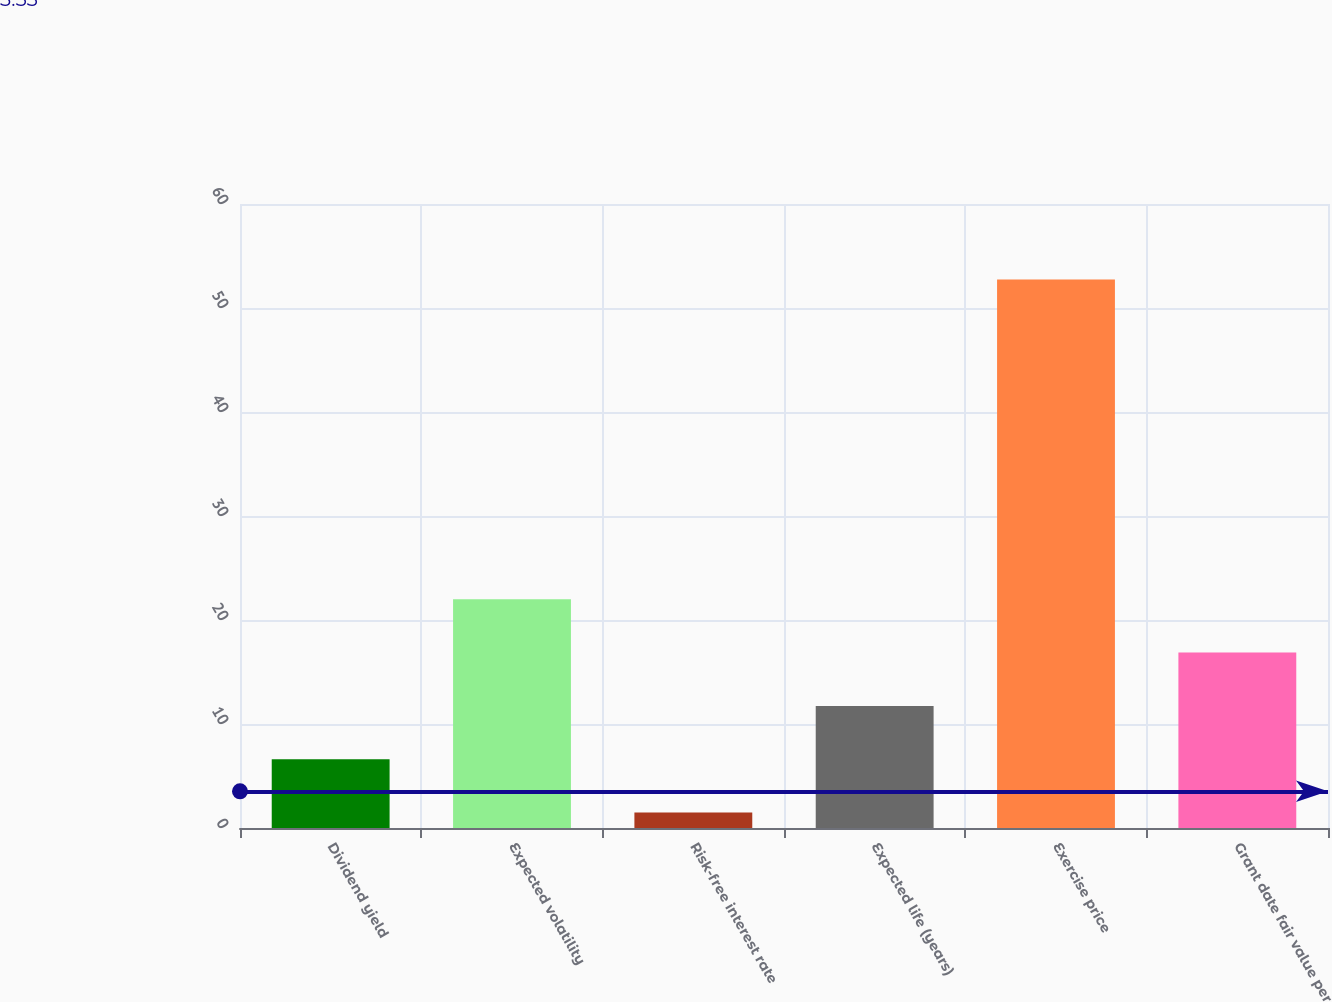Convert chart to OTSL. <chart><loc_0><loc_0><loc_500><loc_500><bar_chart><fcel>Dividend yield<fcel>Expected volatility<fcel>Risk-free interest rate<fcel>Expected life (years)<fcel>Exercise price<fcel>Grant date fair value per<nl><fcel>6.61<fcel>22<fcel>1.48<fcel>11.74<fcel>52.75<fcel>16.87<nl></chart> 